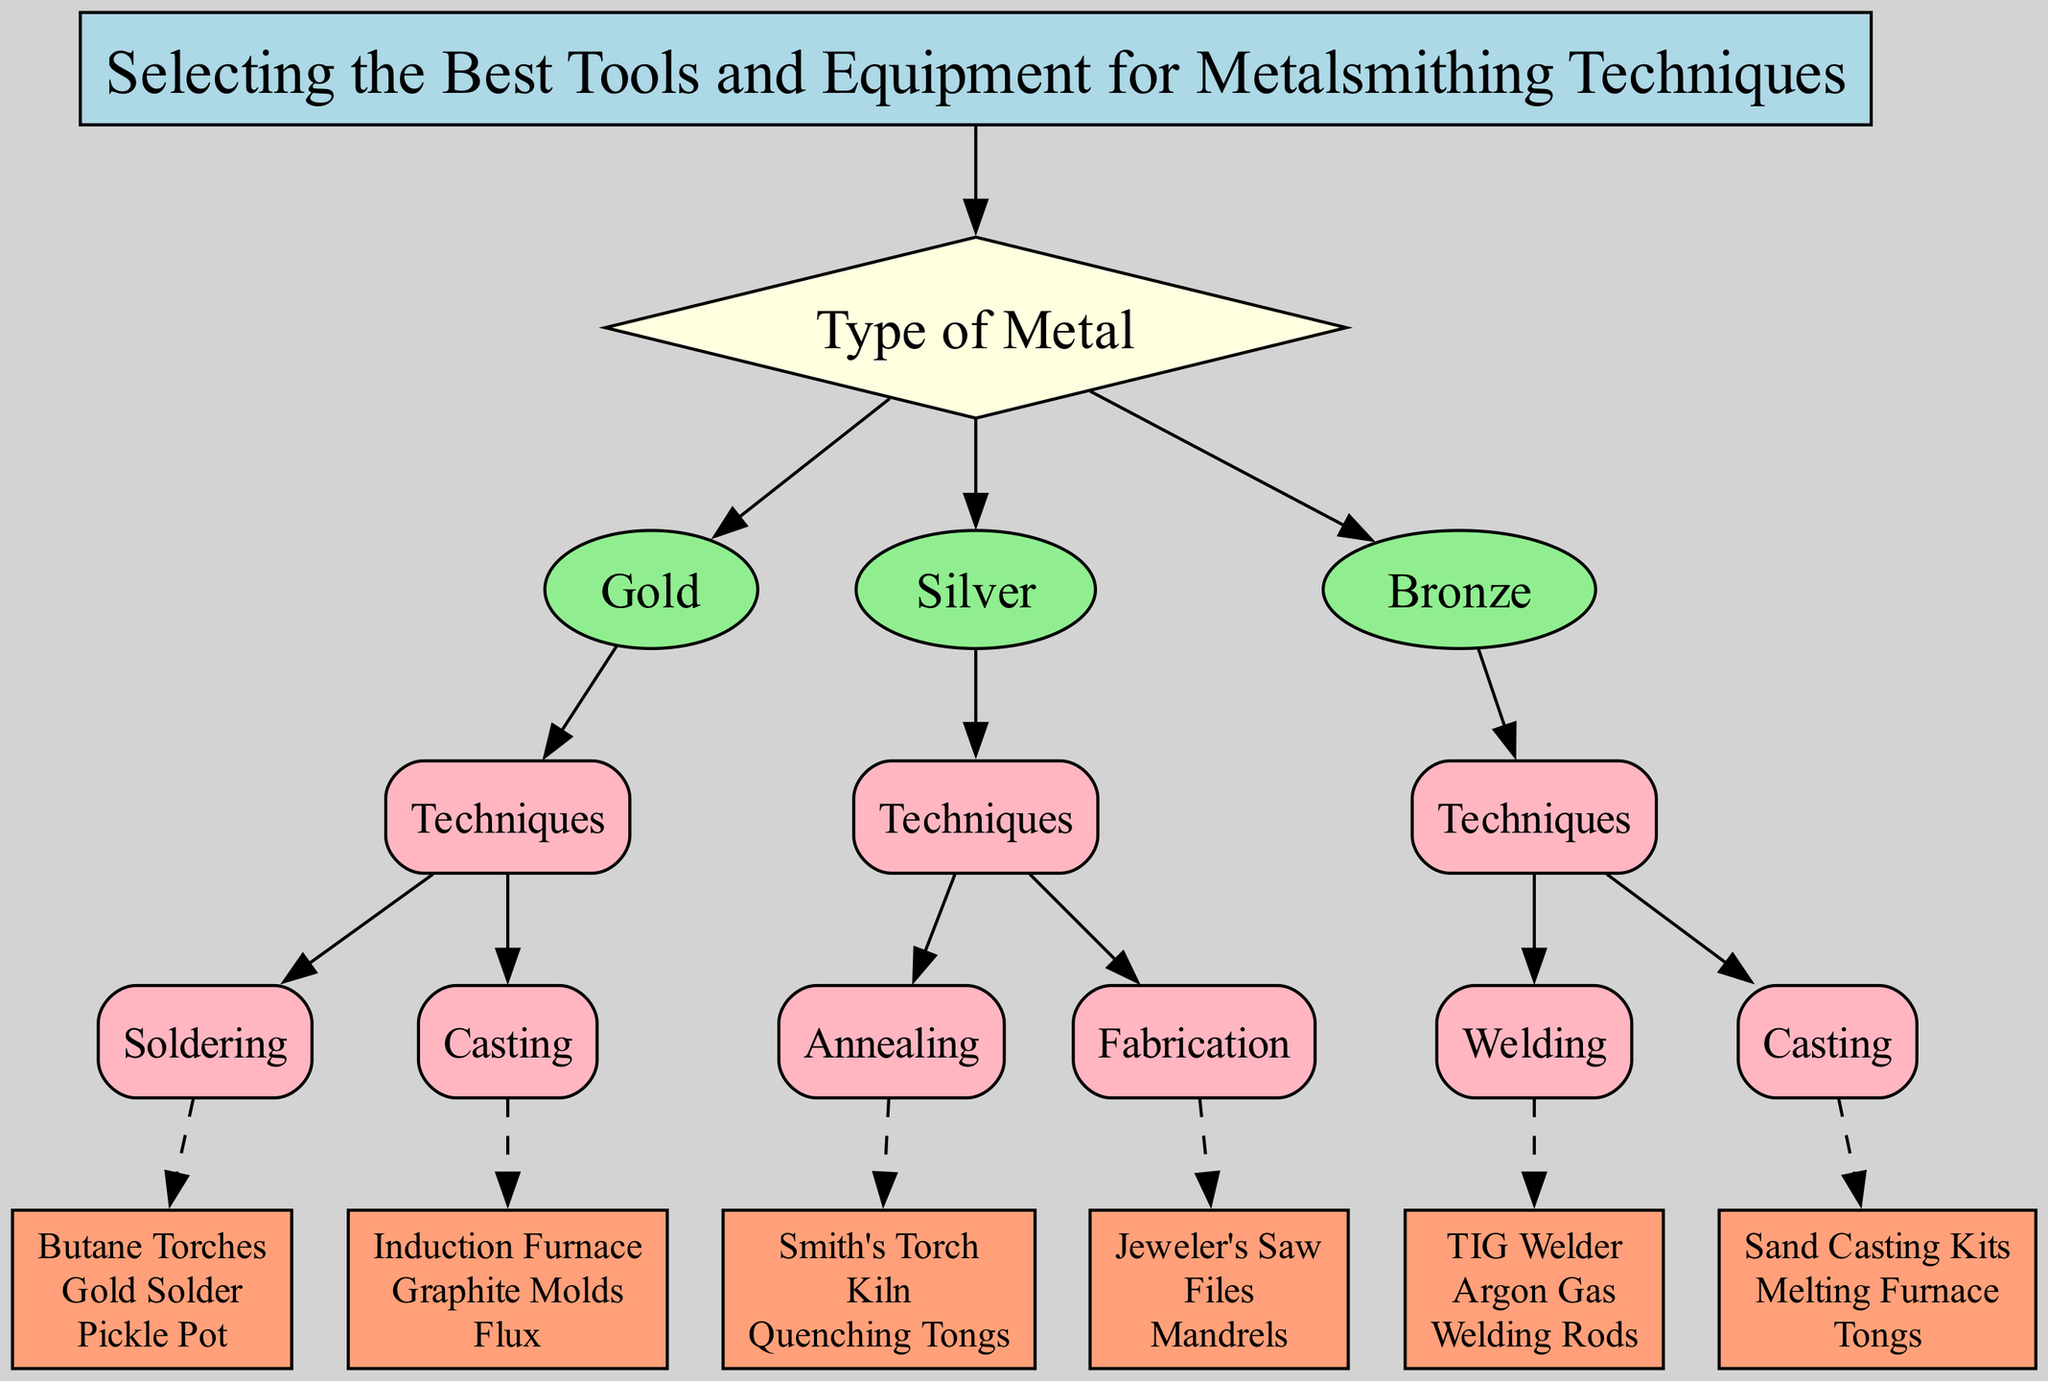What is the first node in the decision tree? The first node is the root node, which represents the primary decision point for the selection of tools and equipment for metalsmithing techniques. According to the diagram, this node is labeled "Selecting the Best Tools and Equipment for Metalsmithing Techniques."
Answer: Selecting the Best Tools and Equipment for Metalsmithing Techniques How many types of metals are there in the diagram? The diagram contains three main branches under the initial "Type of Metal" node: Gold, Silver, and Bronze. Therefore, there are three types of metals represented in the decision tree.
Answer: 3 What tools are listed under the Gold Casting technique? To find the tools for the Gold Casting technique, I look under the Gold node and then down the children to the Casting technique. The tools listed for this technique are "Induction Furnace," "Graphite Molds," and "Flux."
Answer: Induction Furnace, Graphite Molds, Flux What is the relationship between Silver and Fabrication? In the decision tree, Silver is a parent node that leads to the Techniques node, which includes a child node for Fabrication. This shows that Fabrication is a technique specifically associated with Silver.
Answer: Parent-Child What tools are used for Welding in relation to Bronze? By examining the Bronze node and its children, I see that Welding techniques are outlined under this node. The tools listed for Welding are "TIG Welder," "Argon Gas," and "Welding Rods." Thus, these tools are specifically used for Bronze Welding.
Answer: TIG Welder, Argon Gas, Welding Rods Which metal technique uses a Kiln? The Kiln is mentioned under "Annealing" as a technique related specifically to Silver. Therefore, the technique that uses a Kiln is Annealing, associated with Silver.
Answer: Annealing Which technique uses Smith's Torch and what metal is it associated with? Upon checking the Silver node under Techniques, Smith's Torch is listed as a tool for the Annealing technique. Thus, the technique that uses Smith's Torch is Annealing, which is associated with Silver.
Answer: Annealing, Silver How many techniques are there for Bronze? In the Bronze section of the decision tree, there are two techniques listed under it: Welding and Casting. Therefore, there are two techniques for Bronze found in the diagram.
Answer: 2 What color represents the tools in the diagram? The tools in the decision tree are represented by boxes filled with a specific color. According to the diagram's description, the color for the tools' boxes is "lightsalmon."
Answer: lightsalmon 